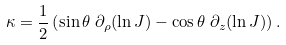<formula> <loc_0><loc_0><loc_500><loc_500>\kappa & = \frac { 1 } { 2 } \left ( \sin \theta \ \partial _ { \rho } ( \ln J ) - \cos \theta \ \partial _ { z } ( \ln J ) \right ) .</formula> 